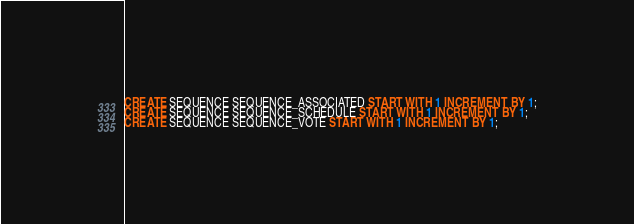Convert code to text. <code><loc_0><loc_0><loc_500><loc_500><_SQL_>CREATE SEQUENCE SEQUENCE_ASSOCIATED START WITH 1 INCREMENT BY 1;
CREATE SEQUENCE SEQUENCE_SCHEDULE START WITH 1 INCREMENT BY 1;
CREATE SEQUENCE SEQUENCE_VOTE START WITH 1 INCREMENT BY 1;</code> 